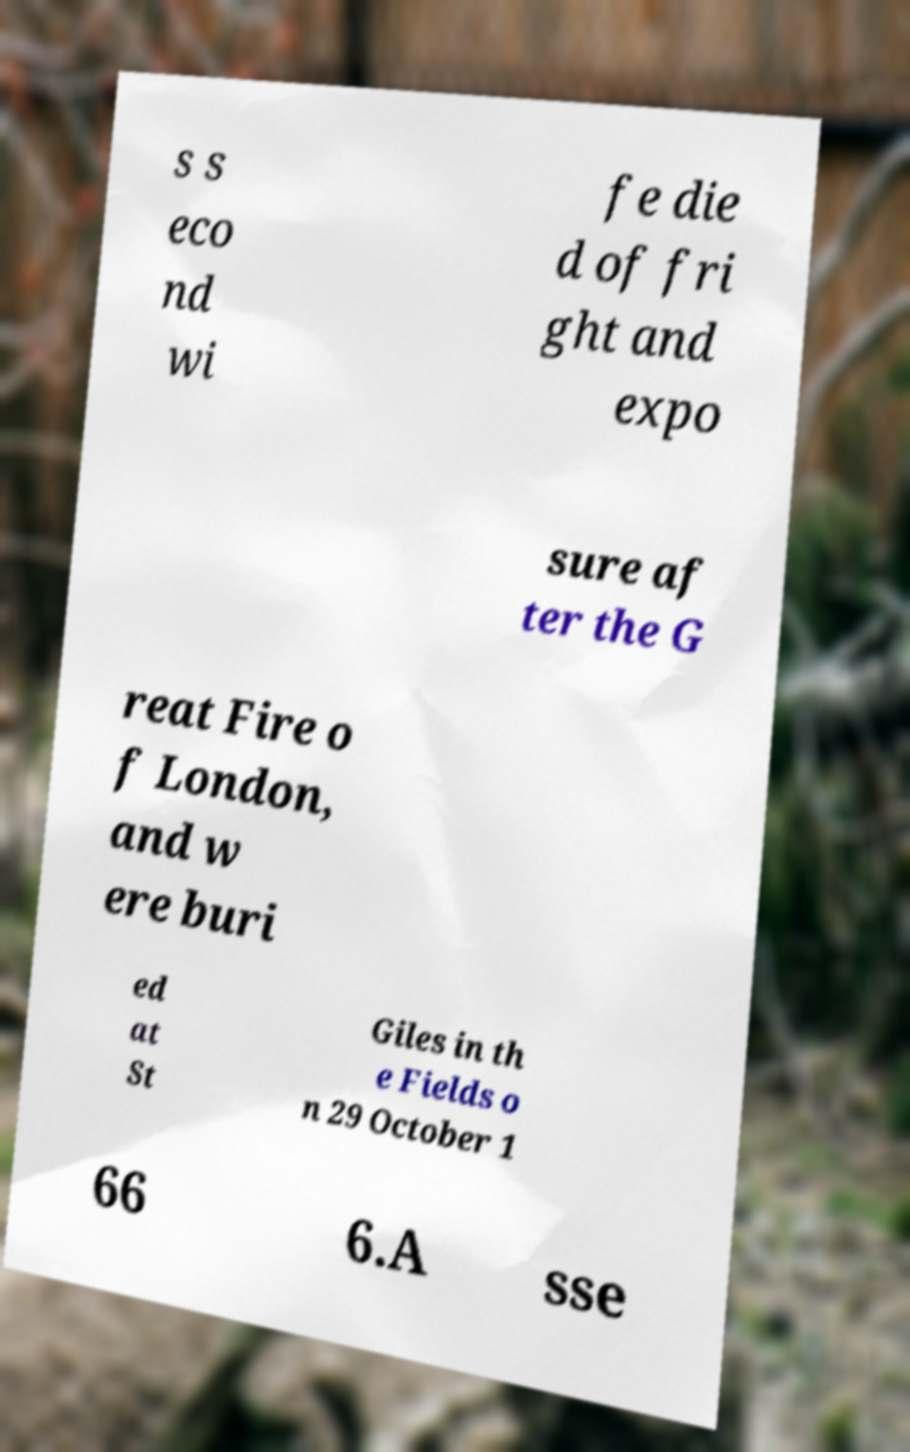Can you read and provide the text displayed in the image?This photo seems to have some interesting text. Can you extract and type it out for me? s s eco nd wi fe die d of fri ght and expo sure af ter the G reat Fire o f London, and w ere buri ed at St Giles in th e Fields o n 29 October 1 66 6.A sse 